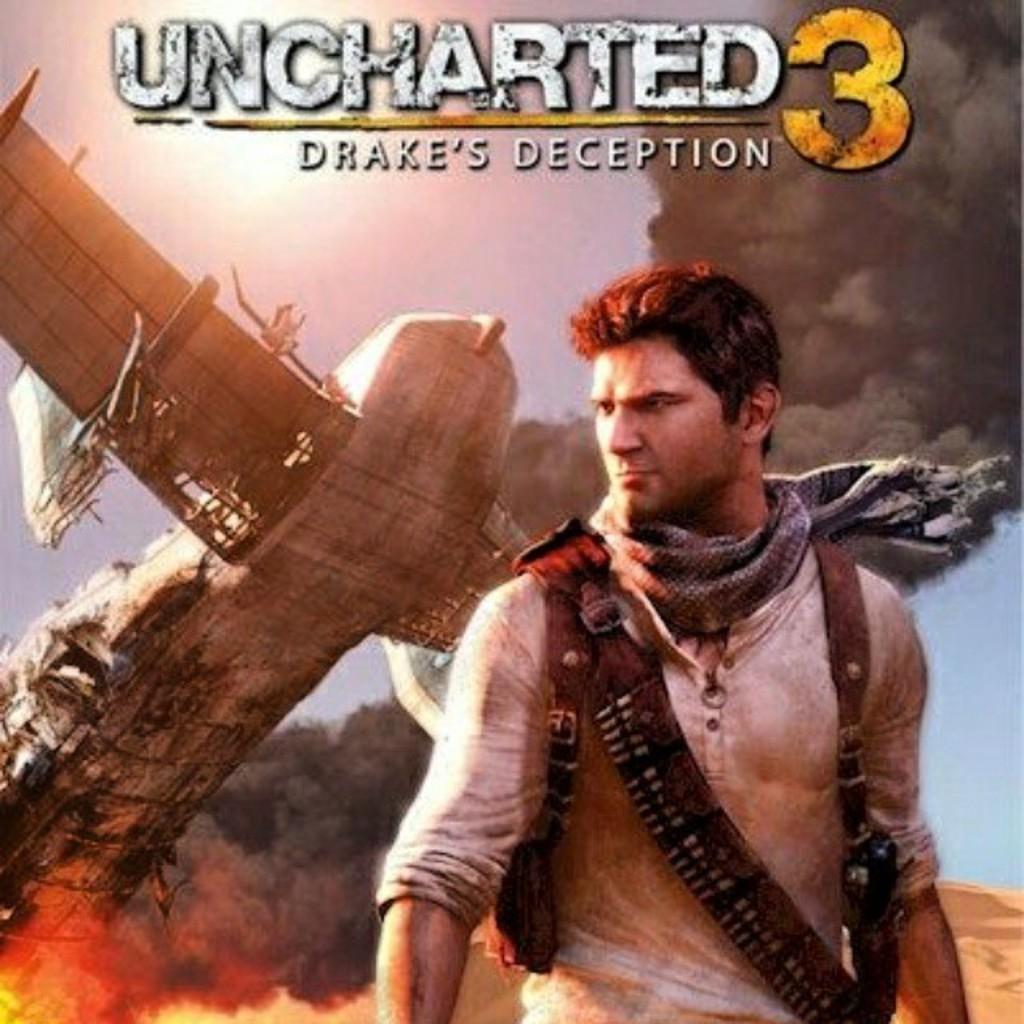What is the name of this game?
Your answer should be compact. Uncharted 3. Which order of uncharted game is this?
Give a very brief answer. 3. 